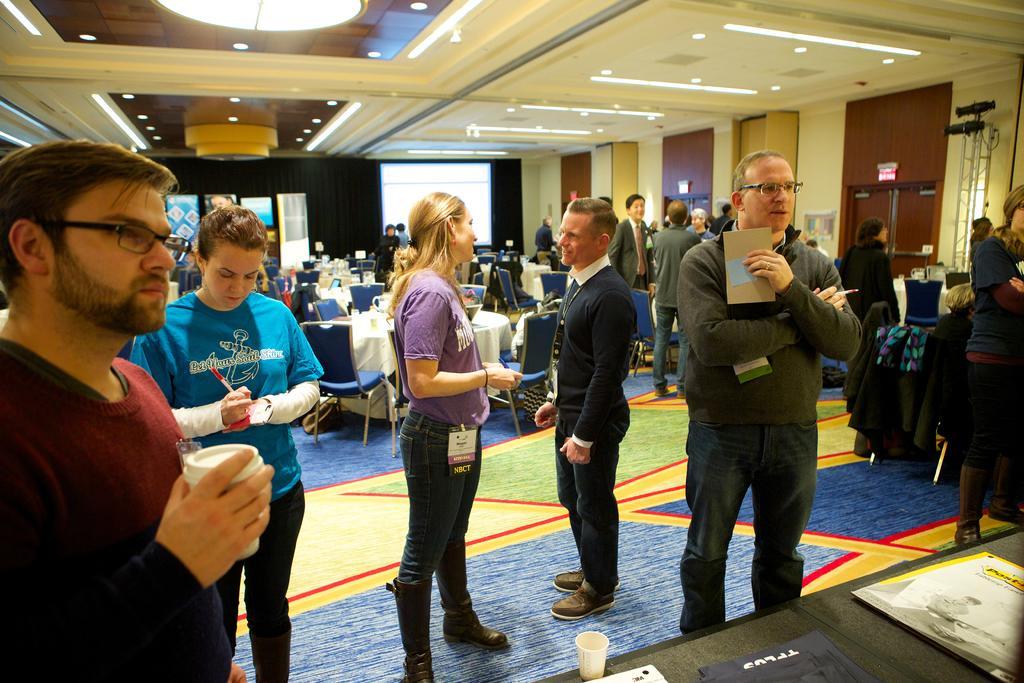Can you describe this image briefly? In this image there is a group of people standing by holding some objects in their hands, behind them there are a few people sitting in chairs. In front of them on the table there are some objects. In the background of the image there are banners, screen and sign boards on the doors and some other objects. At the top of the image there are lamps. 